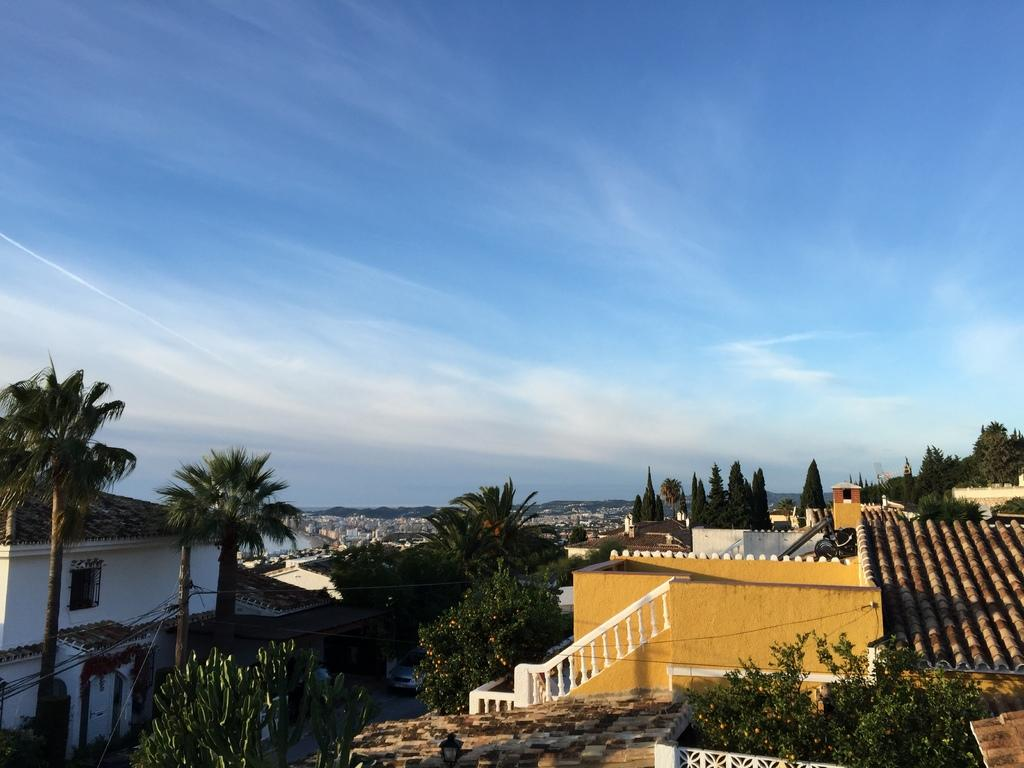What type of structures can be seen in the image? There are buildings in the image. What other natural elements are present in the image? There are plants, trees, and the sky visible in the image. Can you describe the road in the image? There is a car on the road in the image. What else can be seen in the image related to infrastructure? There is a pole with wires in the image. What is the condition of the sky in the image? The sky is visible in the background of the image, and there are clouds in the sky. What type of acoustics can be heard from the cart in the image? There is no cart present in the image, so it is not possible to determine the acoustics. How many parcels are visible in the image? There are no parcels present in the image. 